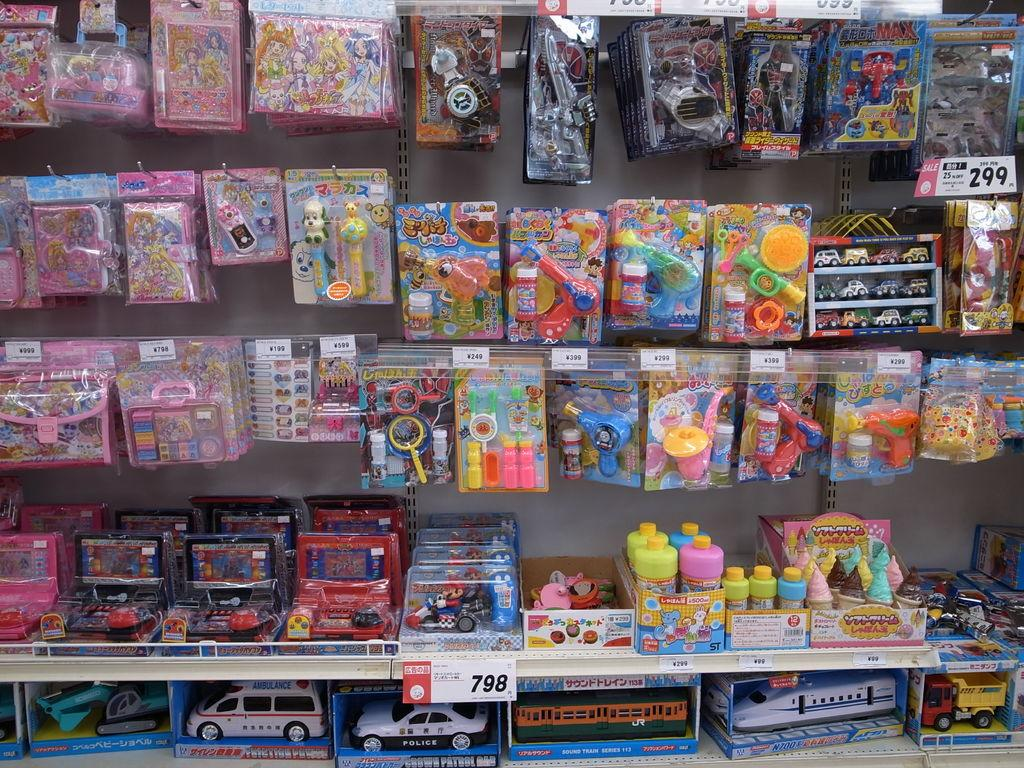<image>
Present a compact description of the photo's key features. Toys hanging on a wall that are on sale for 25% off. 